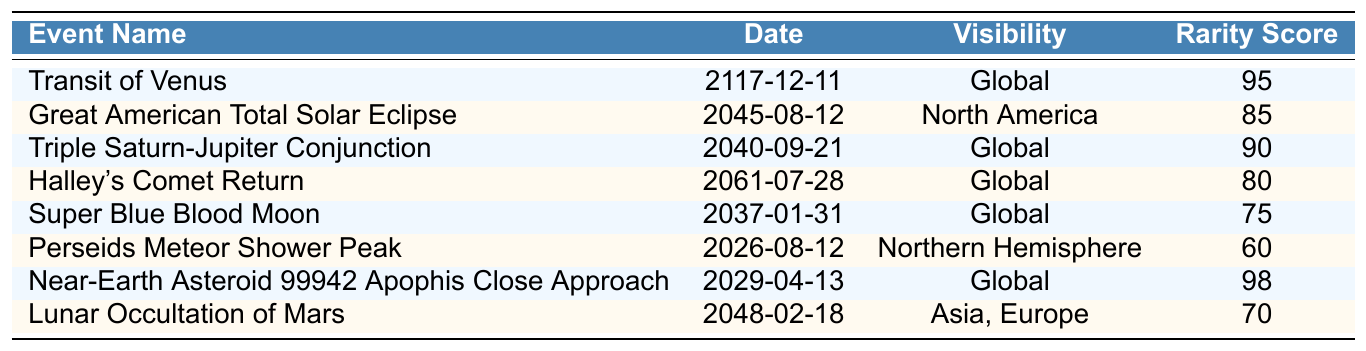What is the date of the Great American Total Solar Eclipse? The table lists the event "Great American Total Solar Eclipse" and shows that its date is "2045-08-12".
Answer: 2045-08-12 Which celestial event has the highest rarity score? By examining the rarity scores in the table, I find "Near-Earth Asteroid 99942 Apophis Close Approach" with a rarity score of 98 is the highest.
Answer: Near-Earth Asteroid 99942 Apophis Close Approach How many celestial events are visible globally? There are 4 events listed with "Global" under the visibility column: Transit of Venus, Triple Saturn-Jupiter Conjunction, Halley's Comet Return, and Near-Earth Asteroid 99942 Apophis Close Approach.
Answer: 4 Is Halley's Comet Return visible from North America? Checking the visibility column for "Halley's Comet Return", it states it is visible globally, not specifically from North America.
Answer: No What is the average rarity score of the events visible from North America? The only event visible from North America is the "Great American Total Solar Eclipse" with a score of 85; thus the average is 85.
Answer: 85 Which event occurs closest to the year 2030? Looking through the table, "Near-Earth Asteroid 99942 Apophis Close Approach" on "2029-04-13" is the closest event to the year 2030.
Answer: Near-Earth Asteroid 99942 Apophis Close Approach Is there an event that occurs in the year 2026? Consulting the table reveals "Perseids Meteor Shower Peak" occurs on "2026-08-12".
Answer: Yes What is the difference in rarity scores between the Super Blue Blood Moon and the Lunar Occultation of Mars? The rarity score for the Super Blue Blood Moon is 75 and for the Lunar Occultation of Mars is 70, thus the difference is 75 - 70 = 5.
Answer: 5 How many celestial events have a rarity score above 80? The events with scores above 80 are: Transit of Venus (95), Great American Total Solar Eclipse (85), Triple Saturn-Jupiter Conjunction (90), and Near-Earth Asteroid 99942 Apophis Close Approach (98), totaling 4 events.
Answer: 4 Which celestial events can be observed in Asia and Europe? The table indicates that "Lunar Occultation of Mars" is the only event that can be observed in both Asia and Europe.
Answer: Lunar Occultation of Mars 